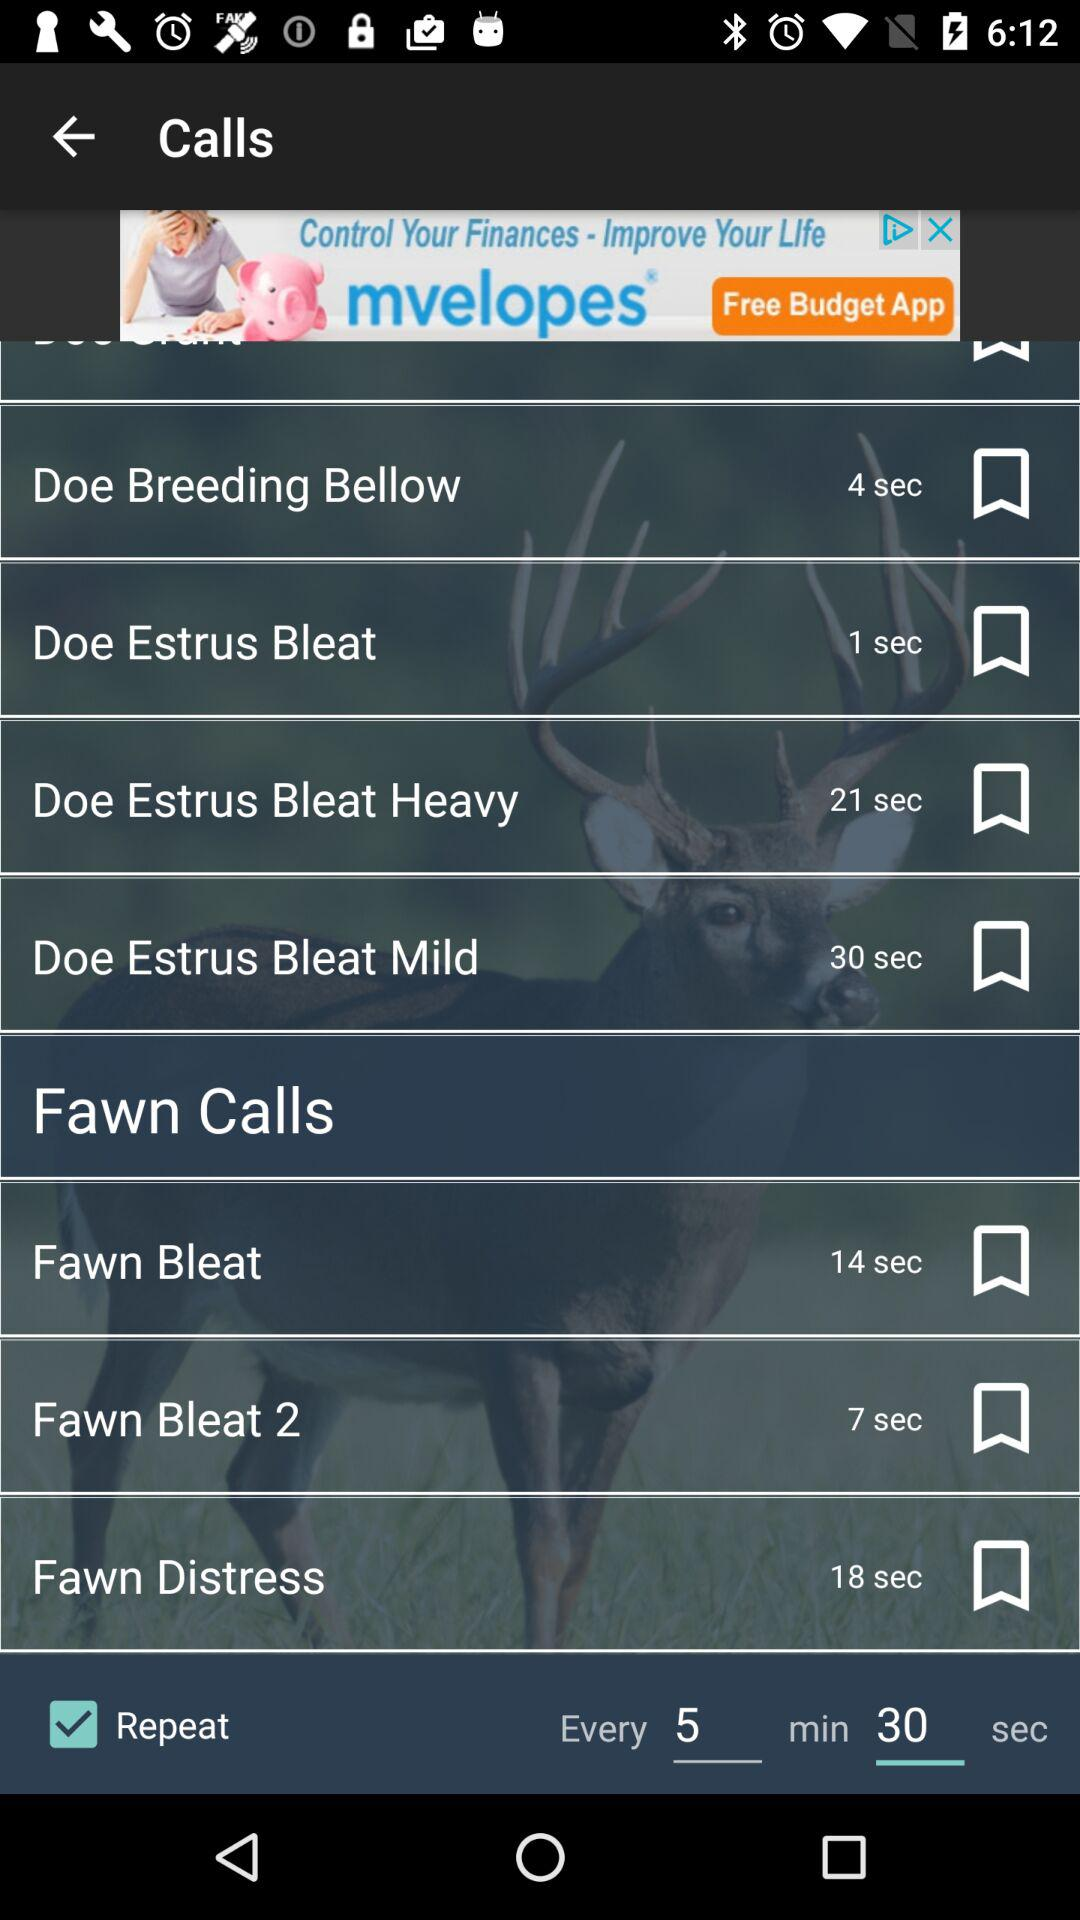What is the time interval between repetitions? The time interval between repetitions is 5 minutes 30 seconds. 